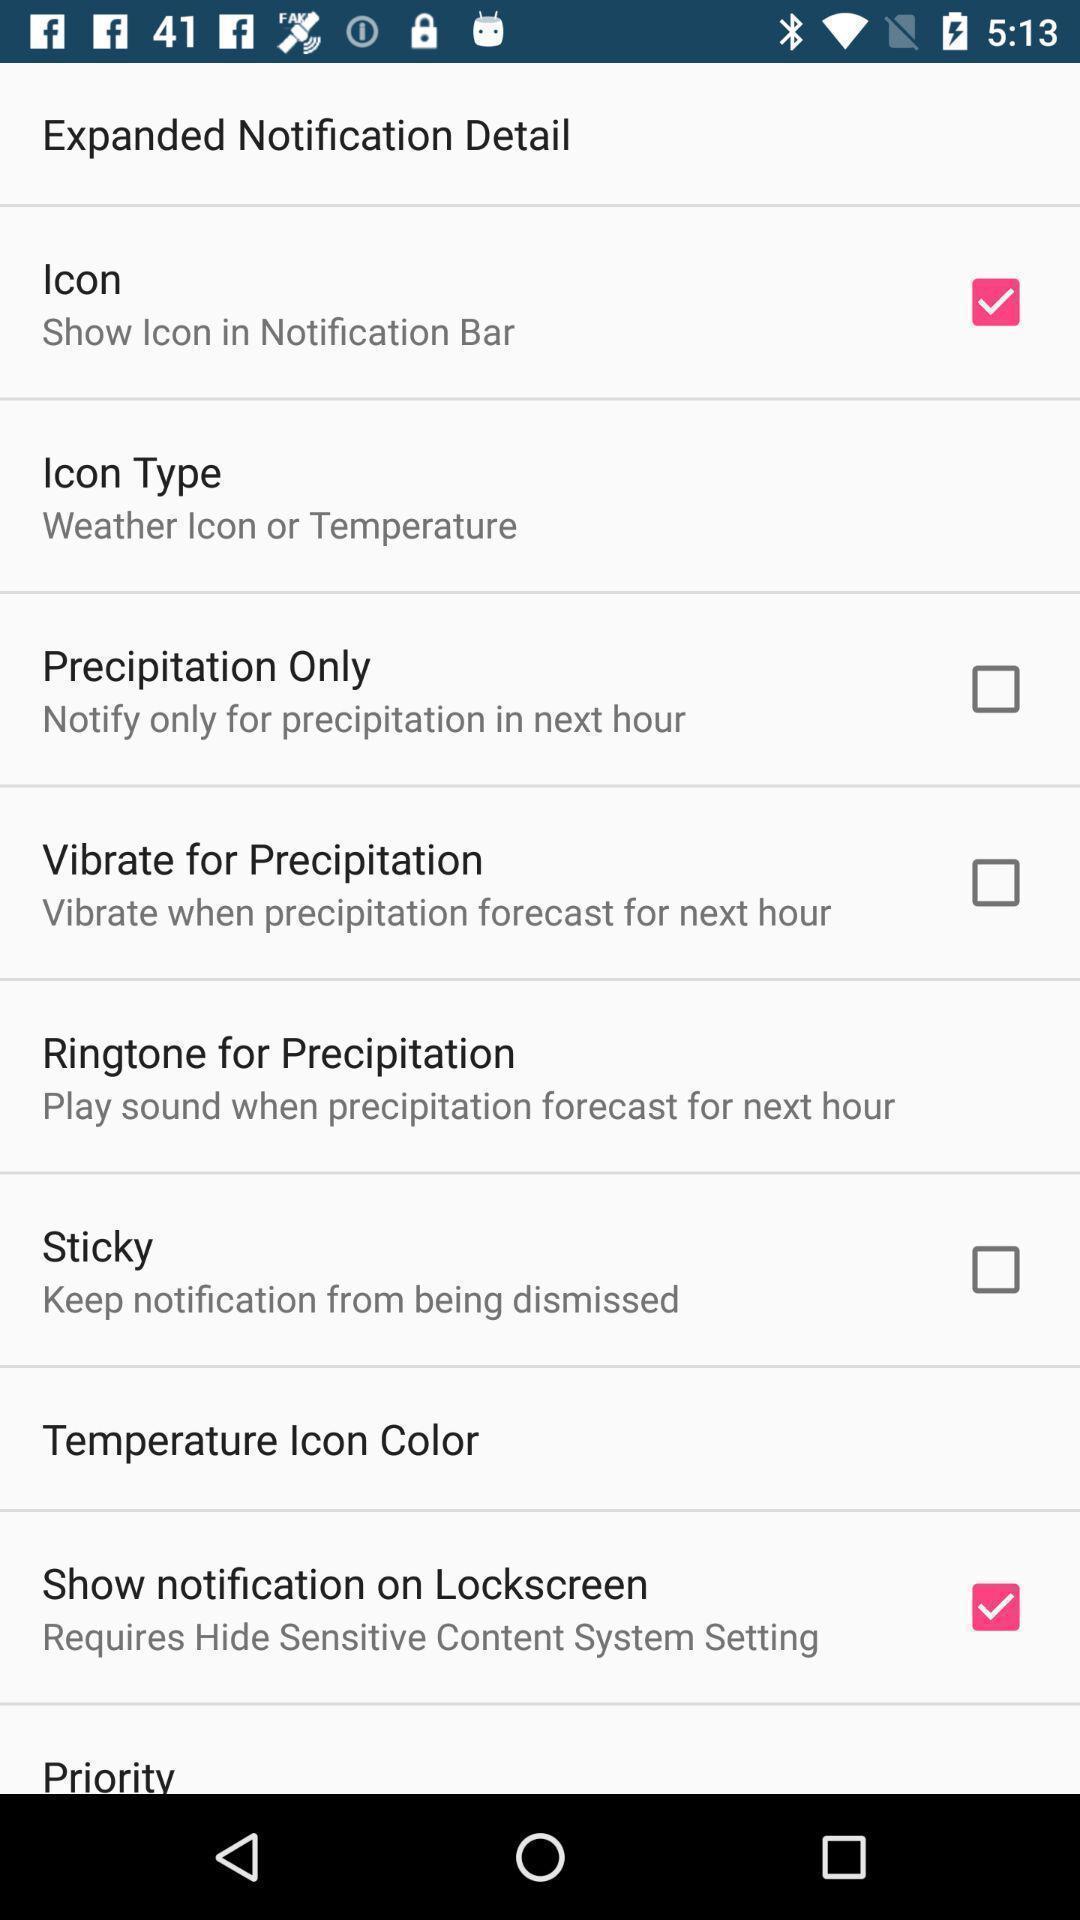Describe the visual elements of this screenshot. Page displaying with list of different settings. 